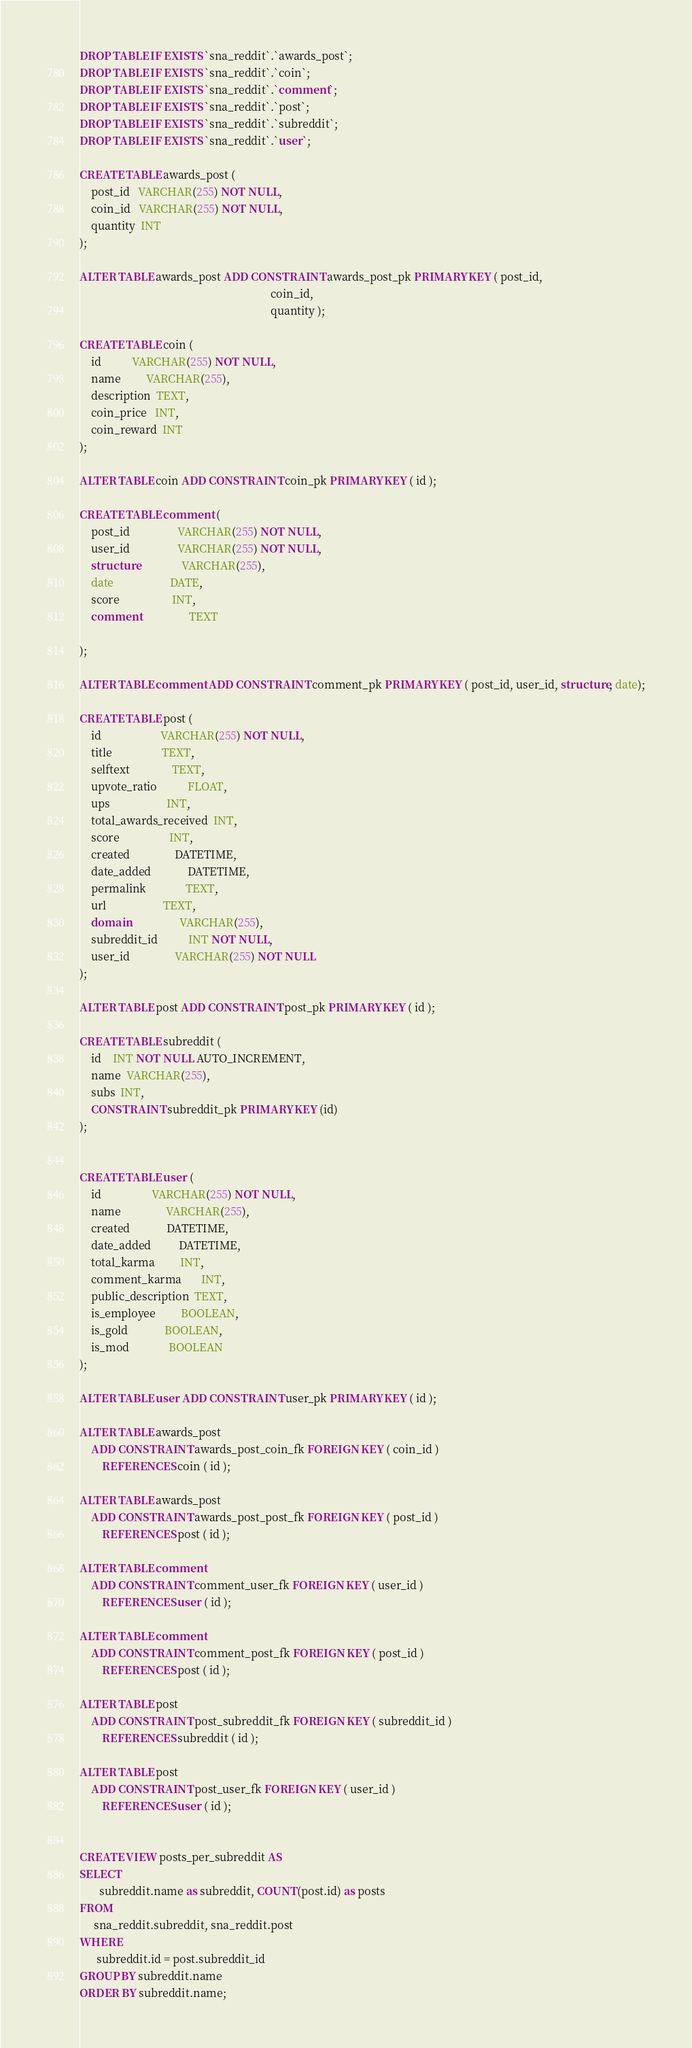<code> <loc_0><loc_0><loc_500><loc_500><_SQL_>DROP TABLE IF EXISTS `sna_reddit`.`awards_post`;
DROP TABLE IF EXISTS `sna_reddit`.`coin`;
DROP TABLE IF EXISTS `sna_reddit`.`comment`;
DROP TABLE IF EXISTS `sna_reddit`.`post`;
DROP TABLE IF EXISTS `sna_reddit`.`subreddit`;
DROP TABLE IF EXISTS `sna_reddit`.`user`;

CREATE TABLE awards_post (
    post_id   VARCHAR(255) NOT NULL,
    coin_id   VARCHAR(255) NOT NULL,
    quantity  INT
);

ALTER TABLE awards_post ADD CONSTRAINT awards_post_pk PRIMARY KEY ( post_id,
                                                                    coin_id, 
                                                                    quantity );

CREATE TABLE coin (
    id           VARCHAR(255) NOT NULL,
    name         VARCHAR(255),
    description  TEXT,
    coin_price   INT,
    coin_reward  INT
);

ALTER TABLE coin ADD CONSTRAINT coin_pk PRIMARY KEY ( id );

CREATE TABLE comment (
    post_id                 VARCHAR(255) NOT NULL,
    user_id                 VARCHAR(255) NOT NULL,
    structure               VARCHAR(255),
    date                    DATE,
    score                   INT,
    comment                 TEXT
    
);

ALTER TABLE comment ADD CONSTRAINT comment_pk PRIMARY KEY ( post_id, user_id, structure, date);

CREATE TABLE post (
    id                     VARCHAR(255) NOT NULL,
    title                  TEXT,
    selftext               TEXT,
    upvote_ratio           FLOAT,
    ups                    INT,
    total_awards_received  INT,
    score                  INT,
    created                DATETIME,
    date_added             DATETIME,
    permalink              TEXT,
    url                    TEXT,
    domain                 VARCHAR(255),
    subreddit_id           INT NOT NULL,
    user_id                VARCHAR(255) NOT NULL
);

ALTER TABLE post ADD CONSTRAINT post_pk PRIMARY KEY ( id );

CREATE TABLE subreddit (
    id    INT NOT NULL AUTO_INCREMENT,
    name  VARCHAR(255),
    subs  INT,
    CONSTRAINT subreddit_pk PRIMARY KEY (id)
);


CREATE TABLE user (
    id                  VARCHAR(255) NOT NULL,
    name                VARCHAR(255),
    created             DATETIME,
    date_added          DATETIME,
    total_karma         INT,
    comment_karma       INT,
    public_description  TEXT,
    is_employee         BOOLEAN,
    is_gold             BOOLEAN,
    is_mod              BOOLEAN
);

ALTER TABLE user ADD CONSTRAINT user_pk PRIMARY KEY ( id );

ALTER TABLE awards_post
    ADD CONSTRAINT awards_post_coin_fk FOREIGN KEY ( coin_id )
        REFERENCES coin ( id );

ALTER TABLE awards_post
    ADD CONSTRAINT awards_post_post_fk FOREIGN KEY ( post_id )
        REFERENCES post ( id );

ALTER TABLE comment
    ADD CONSTRAINT comment_user_fk FOREIGN KEY ( user_id )
        REFERENCES user ( id );
        
ALTER TABLE comment
    ADD CONSTRAINT comment_post_fk FOREIGN KEY ( post_id )
        REFERENCES post ( id );

ALTER TABLE post
    ADD CONSTRAINT post_subreddit_fk FOREIGN KEY ( subreddit_id )
        REFERENCES subreddit ( id );

ALTER TABLE post
    ADD CONSTRAINT post_user_fk FOREIGN KEY ( user_id )
        REFERENCES user ( id );


CREATE VIEW posts_per_subreddit AS
SELECT
       subreddit.name as subreddit, COUNT(post.id) as posts
FROM
     sna_reddit.subreddit, sna_reddit.post
WHERE
      subreddit.id = post.subreddit_id
GROUP BY subreddit.name
ORDER BY subreddit.name;


</code> 